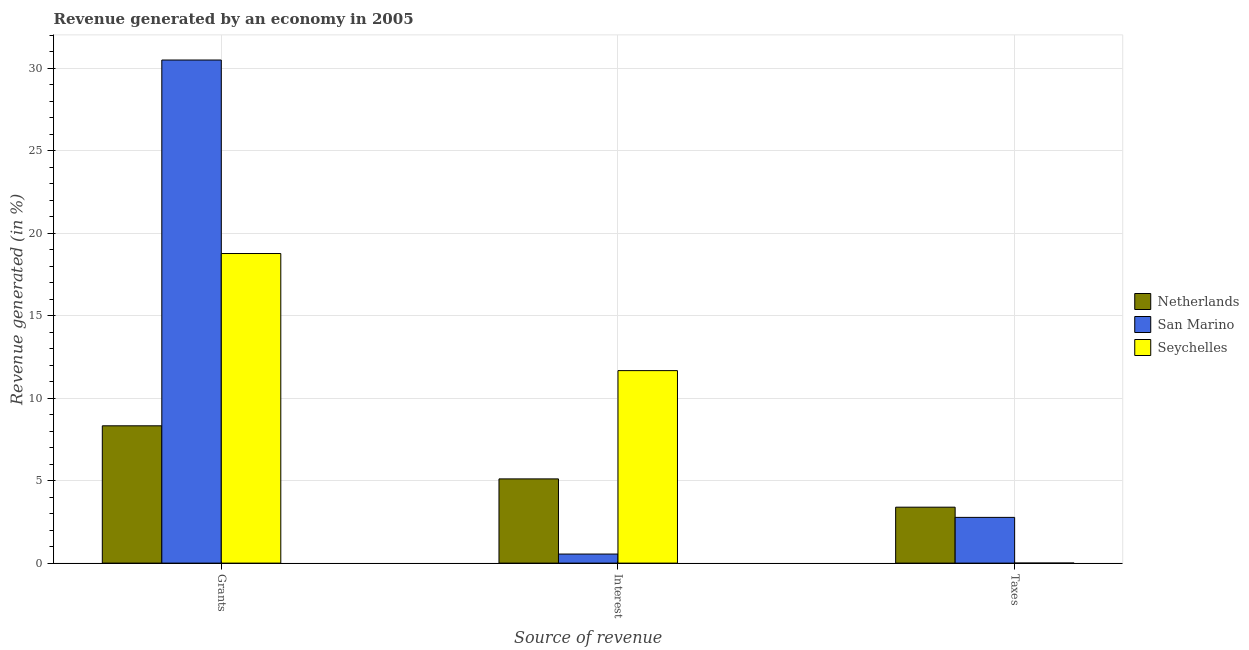How many different coloured bars are there?
Make the answer very short. 3. Are the number of bars per tick equal to the number of legend labels?
Offer a very short reply. Yes. What is the label of the 3rd group of bars from the left?
Your answer should be very brief. Taxes. What is the percentage of revenue generated by taxes in Seychelles?
Offer a terse response. 0. Across all countries, what is the maximum percentage of revenue generated by grants?
Make the answer very short. 30.5. Across all countries, what is the minimum percentage of revenue generated by interest?
Give a very brief answer. 0.55. In which country was the percentage of revenue generated by interest maximum?
Your response must be concise. Seychelles. In which country was the percentage of revenue generated by interest minimum?
Offer a very short reply. San Marino. What is the total percentage of revenue generated by interest in the graph?
Offer a terse response. 17.33. What is the difference between the percentage of revenue generated by grants in Seychelles and that in San Marino?
Ensure brevity in your answer.  -11.73. What is the difference between the percentage of revenue generated by taxes in San Marino and the percentage of revenue generated by interest in Netherlands?
Your response must be concise. -2.33. What is the average percentage of revenue generated by taxes per country?
Provide a succinct answer. 2.06. What is the difference between the percentage of revenue generated by interest and percentage of revenue generated by grants in Seychelles?
Offer a very short reply. -7.1. What is the ratio of the percentage of revenue generated by taxes in San Marino to that in Seychelles?
Keep it short and to the point. 2524.53. Is the percentage of revenue generated by interest in San Marino less than that in Netherlands?
Keep it short and to the point. Yes. Is the difference between the percentage of revenue generated by grants in San Marino and Seychelles greater than the difference between the percentage of revenue generated by interest in San Marino and Seychelles?
Give a very brief answer. Yes. What is the difference between the highest and the second highest percentage of revenue generated by grants?
Your answer should be very brief. 11.73. What is the difference between the highest and the lowest percentage of revenue generated by taxes?
Your answer should be very brief. 3.39. In how many countries, is the percentage of revenue generated by taxes greater than the average percentage of revenue generated by taxes taken over all countries?
Your response must be concise. 2. Is the sum of the percentage of revenue generated by taxes in San Marino and Seychelles greater than the maximum percentage of revenue generated by interest across all countries?
Make the answer very short. No. What does the 3rd bar from the left in Grants represents?
Offer a terse response. Seychelles. What does the 2nd bar from the right in Interest represents?
Provide a short and direct response. San Marino. Is it the case that in every country, the sum of the percentage of revenue generated by grants and percentage of revenue generated by interest is greater than the percentage of revenue generated by taxes?
Offer a very short reply. Yes. How many bars are there?
Give a very brief answer. 9. Are all the bars in the graph horizontal?
Make the answer very short. No. What is the difference between two consecutive major ticks on the Y-axis?
Your answer should be compact. 5. Are the values on the major ticks of Y-axis written in scientific E-notation?
Provide a succinct answer. No. How many legend labels are there?
Offer a terse response. 3. How are the legend labels stacked?
Offer a terse response. Vertical. What is the title of the graph?
Provide a short and direct response. Revenue generated by an economy in 2005. Does "Hungary" appear as one of the legend labels in the graph?
Offer a very short reply. No. What is the label or title of the X-axis?
Provide a short and direct response. Source of revenue. What is the label or title of the Y-axis?
Provide a short and direct response. Revenue generated (in %). What is the Revenue generated (in %) in Netherlands in Grants?
Your answer should be compact. 8.33. What is the Revenue generated (in %) of San Marino in Grants?
Offer a terse response. 30.5. What is the Revenue generated (in %) of Seychelles in Grants?
Offer a terse response. 18.77. What is the Revenue generated (in %) of Netherlands in Interest?
Keep it short and to the point. 5.11. What is the Revenue generated (in %) in San Marino in Interest?
Give a very brief answer. 0.55. What is the Revenue generated (in %) in Seychelles in Interest?
Ensure brevity in your answer.  11.67. What is the Revenue generated (in %) of Netherlands in Taxes?
Provide a short and direct response. 3.39. What is the Revenue generated (in %) of San Marino in Taxes?
Your response must be concise. 2.77. What is the Revenue generated (in %) in Seychelles in Taxes?
Ensure brevity in your answer.  0. Across all Source of revenue, what is the maximum Revenue generated (in %) of Netherlands?
Your answer should be compact. 8.33. Across all Source of revenue, what is the maximum Revenue generated (in %) of San Marino?
Provide a succinct answer. 30.5. Across all Source of revenue, what is the maximum Revenue generated (in %) in Seychelles?
Make the answer very short. 18.77. Across all Source of revenue, what is the minimum Revenue generated (in %) of Netherlands?
Your response must be concise. 3.39. Across all Source of revenue, what is the minimum Revenue generated (in %) in San Marino?
Ensure brevity in your answer.  0.55. Across all Source of revenue, what is the minimum Revenue generated (in %) of Seychelles?
Your response must be concise. 0. What is the total Revenue generated (in %) of Netherlands in the graph?
Make the answer very short. 16.82. What is the total Revenue generated (in %) of San Marino in the graph?
Make the answer very short. 33.82. What is the total Revenue generated (in %) in Seychelles in the graph?
Your response must be concise. 30.44. What is the difference between the Revenue generated (in %) in Netherlands in Grants and that in Interest?
Make the answer very short. 3.22. What is the difference between the Revenue generated (in %) in San Marino in Grants and that in Interest?
Provide a succinct answer. 29.95. What is the difference between the Revenue generated (in %) in Seychelles in Grants and that in Interest?
Ensure brevity in your answer.  7.1. What is the difference between the Revenue generated (in %) of Netherlands in Grants and that in Taxes?
Your answer should be compact. 4.93. What is the difference between the Revenue generated (in %) of San Marino in Grants and that in Taxes?
Offer a very short reply. 27.73. What is the difference between the Revenue generated (in %) of Seychelles in Grants and that in Taxes?
Make the answer very short. 18.77. What is the difference between the Revenue generated (in %) of Netherlands in Interest and that in Taxes?
Offer a very short reply. 1.71. What is the difference between the Revenue generated (in %) of San Marino in Interest and that in Taxes?
Make the answer very short. -2.22. What is the difference between the Revenue generated (in %) of Seychelles in Interest and that in Taxes?
Your answer should be compact. 11.67. What is the difference between the Revenue generated (in %) in Netherlands in Grants and the Revenue generated (in %) in San Marino in Interest?
Make the answer very short. 7.78. What is the difference between the Revenue generated (in %) in Netherlands in Grants and the Revenue generated (in %) in Seychelles in Interest?
Ensure brevity in your answer.  -3.35. What is the difference between the Revenue generated (in %) of San Marino in Grants and the Revenue generated (in %) of Seychelles in Interest?
Your response must be concise. 18.83. What is the difference between the Revenue generated (in %) of Netherlands in Grants and the Revenue generated (in %) of San Marino in Taxes?
Ensure brevity in your answer.  5.55. What is the difference between the Revenue generated (in %) in Netherlands in Grants and the Revenue generated (in %) in Seychelles in Taxes?
Make the answer very short. 8.32. What is the difference between the Revenue generated (in %) of San Marino in Grants and the Revenue generated (in %) of Seychelles in Taxes?
Offer a terse response. 30.5. What is the difference between the Revenue generated (in %) in Netherlands in Interest and the Revenue generated (in %) in San Marino in Taxes?
Give a very brief answer. 2.33. What is the difference between the Revenue generated (in %) in Netherlands in Interest and the Revenue generated (in %) in Seychelles in Taxes?
Your answer should be very brief. 5.11. What is the difference between the Revenue generated (in %) in San Marino in Interest and the Revenue generated (in %) in Seychelles in Taxes?
Your response must be concise. 0.55. What is the average Revenue generated (in %) of Netherlands per Source of revenue?
Provide a succinct answer. 5.61. What is the average Revenue generated (in %) in San Marino per Source of revenue?
Offer a very short reply. 11.27. What is the average Revenue generated (in %) of Seychelles per Source of revenue?
Give a very brief answer. 10.15. What is the difference between the Revenue generated (in %) in Netherlands and Revenue generated (in %) in San Marino in Grants?
Provide a short and direct response. -22.18. What is the difference between the Revenue generated (in %) in Netherlands and Revenue generated (in %) in Seychelles in Grants?
Provide a succinct answer. -10.45. What is the difference between the Revenue generated (in %) of San Marino and Revenue generated (in %) of Seychelles in Grants?
Make the answer very short. 11.73. What is the difference between the Revenue generated (in %) in Netherlands and Revenue generated (in %) in San Marino in Interest?
Your answer should be compact. 4.56. What is the difference between the Revenue generated (in %) of Netherlands and Revenue generated (in %) of Seychelles in Interest?
Provide a short and direct response. -6.56. What is the difference between the Revenue generated (in %) of San Marino and Revenue generated (in %) of Seychelles in Interest?
Provide a succinct answer. -11.12. What is the difference between the Revenue generated (in %) of Netherlands and Revenue generated (in %) of San Marino in Taxes?
Make the answer very short. 0.62. What is the difference between the Revenue generated (in %) of Netherlands and Revenue generated (in %) of Seychelles in Taxes?
Your answer should be compact. 3.39. What is the difference between the Revenue generated (in %) of San Marino and Revenue generated (in %) of Seychelles in Taxes?
Keep it short and to the point. 2.77. What is the ratio of the Revenue generated (in %) in Netherlands in Grants to that in Interest?
Offer a very short reply. 1.63. What is the ratio of the Revenue generated (in %) in San Marino in Grants to that in Interest?
Your answer should be very brief. 55.53. What is the ratio of the Revenue generated (in %) of Seychelles in Grants to that in Interest?
Keep it short and to the point. 1.61. What is the ratio of the Revenue generated (in %) of Netherlands in Grants to that in Taxes?
Your response must be concise. 2.45. What is the ratio of the Revenue generated (in %) in San Marino in Grants to that in Taxes?
Your response must be concise. 11. What is the ratio of the Revenue generated (in %) of Seychelles in Grants to that in Taxes?
Offer a terse response. 1.71e+04. What is the ratio of the Revenue generated (in %) of Netherlands in Interest to that in Taxes?
Offer a very short reply. 1.51. What is the ratio of the Revenue generated (in %) in San Marino in Interest to that in Taxes?
Provide a short and direct response. 0.2. What is the ratio of the Revenue generated (in %) of Seychelles in Interest to that in Taxes?
Provide a short and direct response. 1.06e+04. What is the difference between the highest and the second highest Revenue generated (in %) in Netherlands?
Make the answer very short. 3.22. What is the difference between the highest and the second highest Revenue generated (in %) of San Marino?
Your answer should be compact. 27.73. What is the difference between the highest and the second highest Revenue generated (in %) of Seychelles?
Give a very brief answer. 7.1. What is the difference between the highest and the lowest Revenue generated (in %) of Netherlands?
Provide a succinct answer. 4.93. What is the difference between the highest and the lowest Revenue generated (in %) of San Marino?
Provide a short and direct response. 29.95. What is the difference between the highest and the lowest Revenue generated (in %) in Seychelles?
Keep it short and to the point. 18.77. 